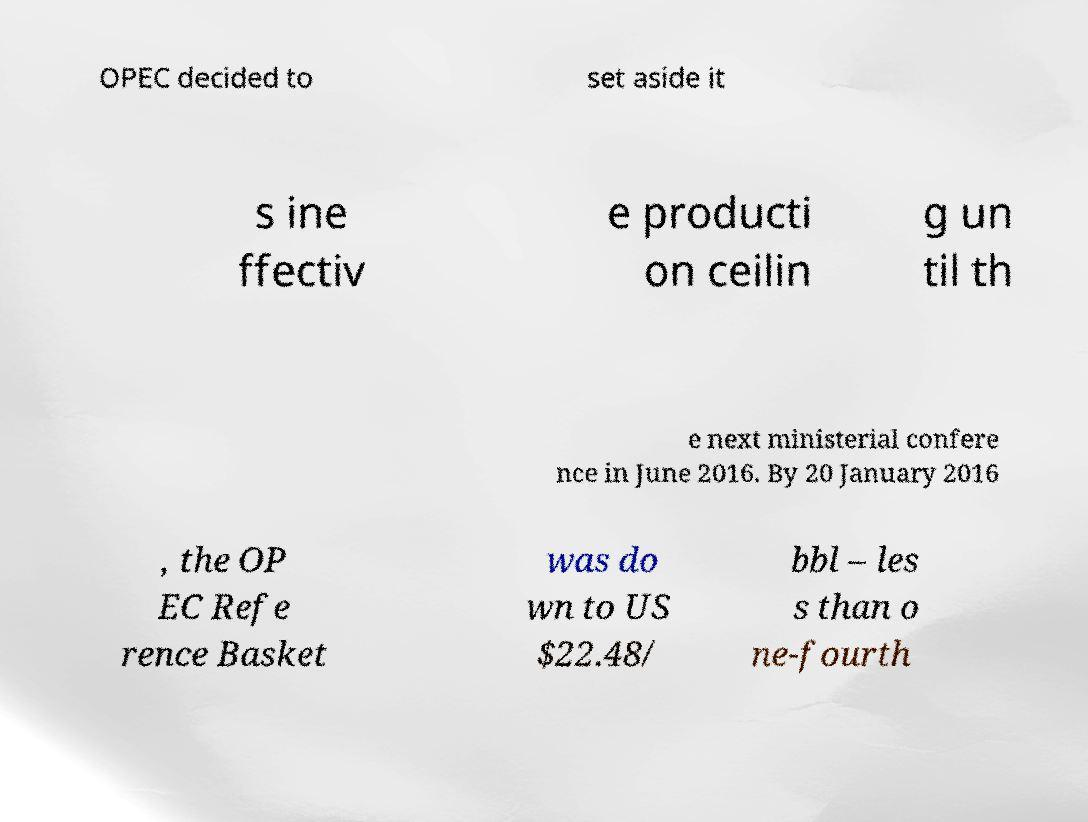Could you extract and type out the text from this image? OPEC decided to set aside it s ine ffectiv e producti on ceilin g un til th e next ministerial confere nce in June 2016. By 20 January 2016 , the OP EC Refe rence Basket was do wn to US $22.48/ bbl – les s than o ne-fourth 